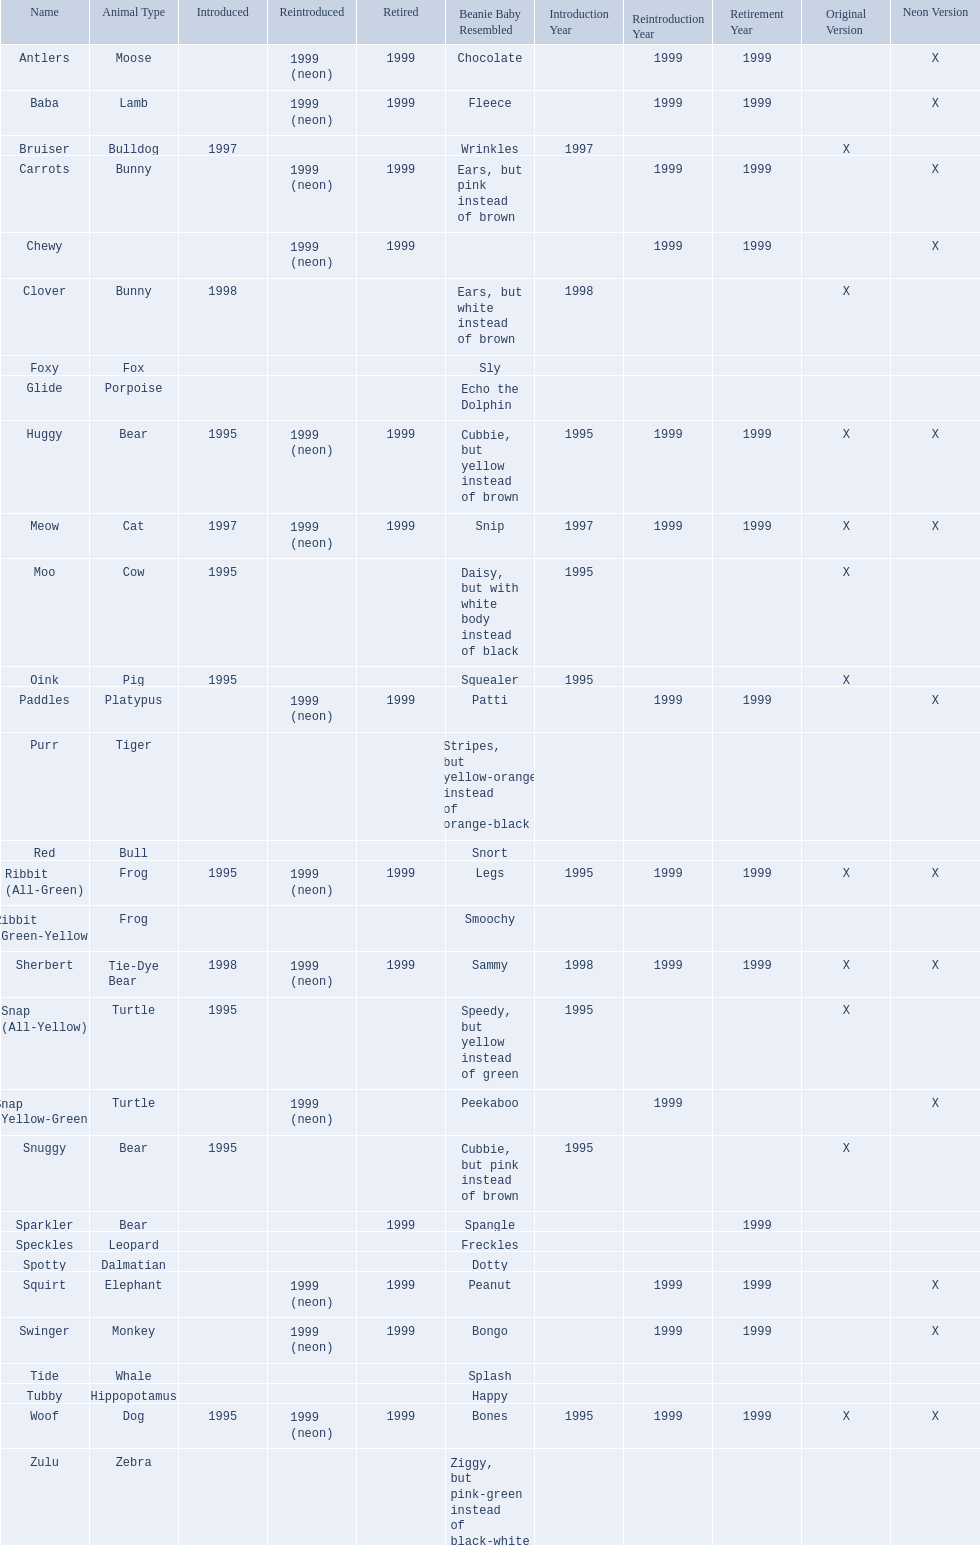What are the types of pillow pal animals? Antlers, Moose, Lamb, Bulldog, Bunny, , Bunny, Fox, Porpoise, Bear, Cat, Cow, Pig, Platypus, Tiger, Bull, Frog, Frog, Tie-Dye Bear, Turtle, Turtle, Bear, Bear, Leopard, Dalmatian, Elephant, Monkey, Whale, Hippopotamus, Dog, Zebra. Of those, which is a dalmatian? Dalmatian. What is the name of the dalmatian? Spotty. 